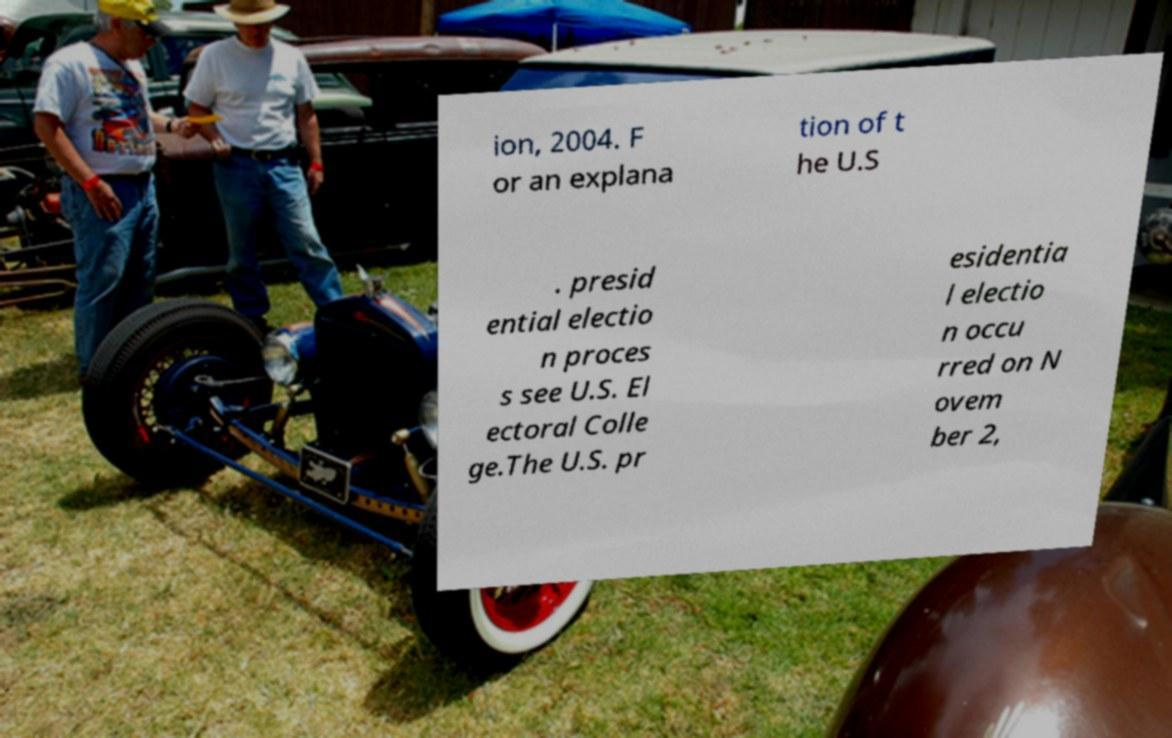Please read and relay the text visible in this image. What does it say? ion, 2004. F or an explana tion of t he U.S . presid ential electio n proces s see U.S. El ectoral Colle ge.The U.S. pr esidentia l electio n occu rred on N ovem ber 2, 